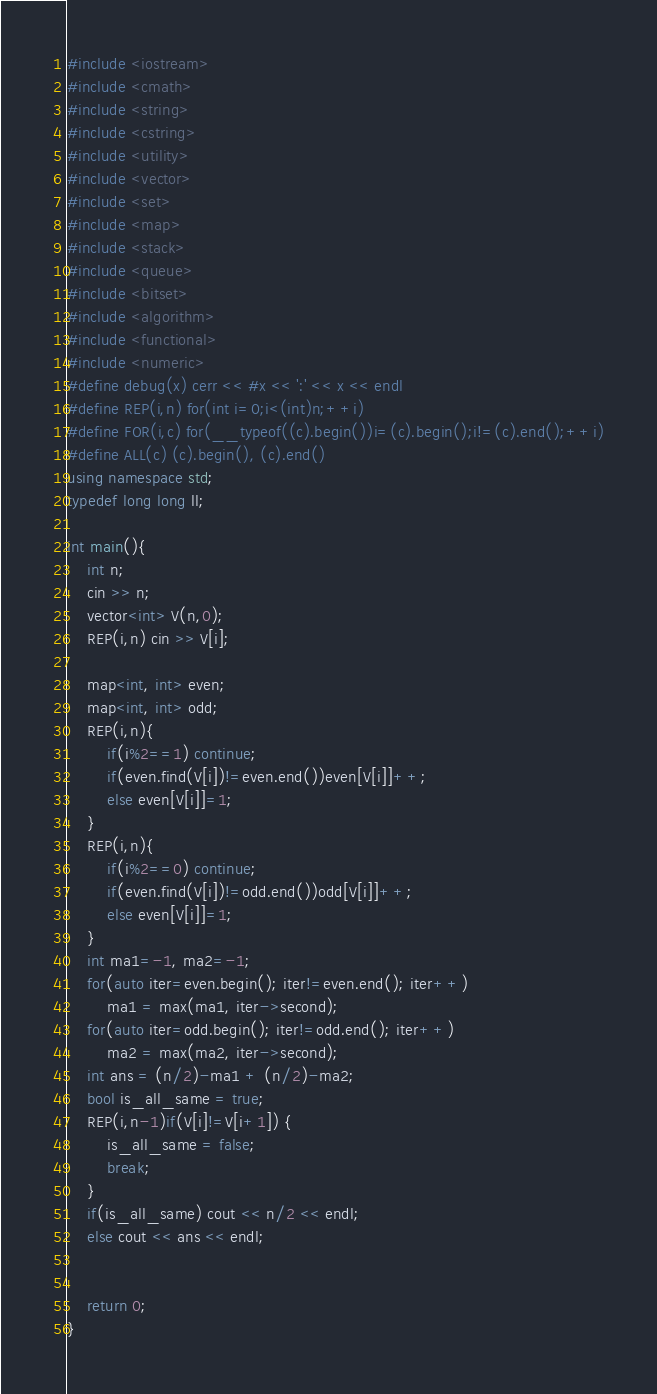<code> <loc_0><loc_0><loc_500><loc_500><_C++_>#include <iostream>
#include <cmath>
#include <string>
#include <cstring>
#include <utility>
#include <vector>
#include <set>
#include <map>
#include <stack>
#include <queue>
#include <bitset>
#include <algorithm>
#include <functional>
#include <numeric>
#define debug(x) cerr << #x << ':' << x << endl
#define REP(i,n) for(int i=0;i<(int)n;++i)
#define FOR(i,c) for(__typeof((c).begin())i=(c).begin();i!=(c).end();++i)
#define ALL(c) (c).begin(), (c).end()
using namespace std;
typedef long long ll;

int main(){
    int n;
    cin >> n;
    vector<int> V(n,0);
    REP(i,n) cin >> V[i];

    map<int, int> even;
    map<int, int> odd;
    REP(i,n){
        if(i%2==1) continue;
        if(even.find(V[i])!=even.end())even[V[i]]++;
        else even[V[i]]=1;
    }
    REP(i,n){
        if(i%2==0) continue;
        if(even.find(V[i])!=odd.end())odd[V[i]]++;
        else even[V[i]]=1;
    }
    int ma1=-1, ma2=-1;
    for(auto iter=even.begin(); iter!=even.end(); iter++)
        ma1 = max(ma1, iter->second);
    for(auto iter=odd.begin(); iter!=odd.end(); iter++)
        ma2 = max(ma2, iter->second);
    int ans = (n/2)-ma1 + (n/2)-ma2;
    bool is_all_same = true;
    REP(i,n-1)if(V[i]!=V[i+1]) {
        is_all_same = false;
        break;
    }
    if(is_all_same) cout << n/2 << endl;
    else cout << ans << endl;


    return 0;
}</code> 